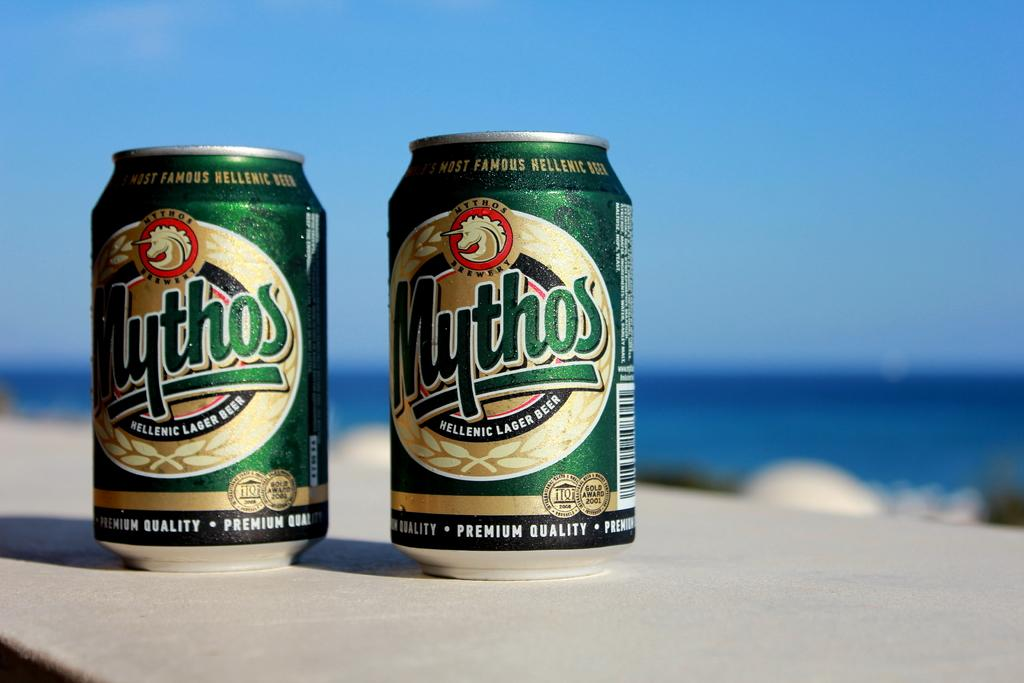<image>
Relay a brief, clear account of the picture shown. Two cans of Mythos in front of a large body of water. 